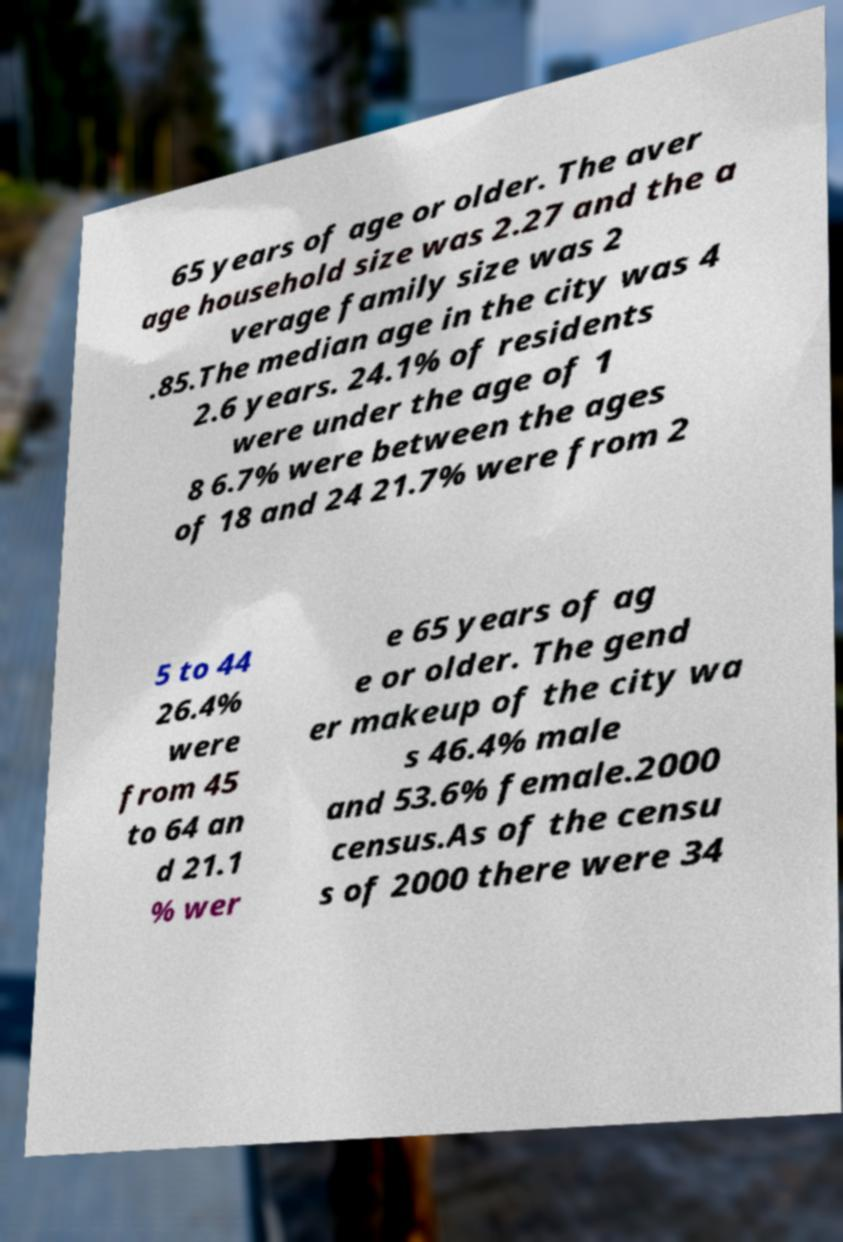For documentation purposes, I need the text within this image transcribed. Could you provide that? 65 years of age or older. The aver age household size was 2.27 and the a verage family size was 2 .85.The median age in the city was 4 2.6 years. 24.1% of residents were under the age of 1 8 6.7% were between the ages of 18 and 24 21.7% were from 2 5 to 44 26.4% were from 45 to 64 an d 21.1 % wer e 65 years of ag e or older. The gend er makeup of the city wa s 46.4% male and 53.6% female.2000 census.As of the censu s of 2000 there were 34 